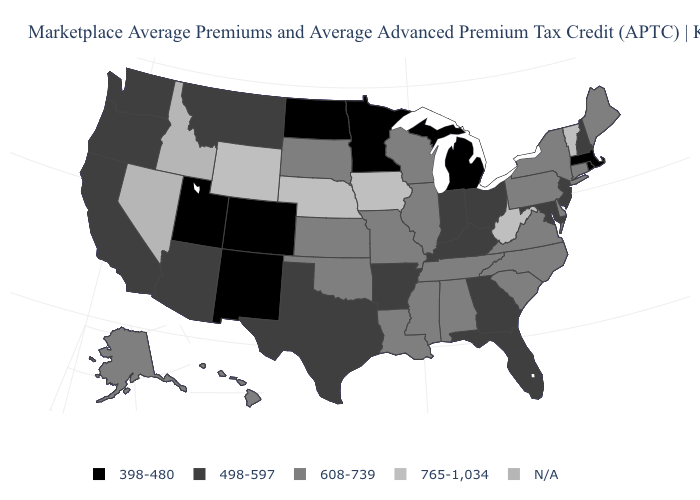Name the states that have a value in the range 498-597?
Be succinct. Arizona, Arkansas, California, Florida, Georgia, Indiana, Kentucky, Maryland, Montana, New Hampshire, New Jersey, Ohio, Oregon, Texas, Washington. What is the value of Minnesota?
Write a very short answer. 398-480. Name the states that have a value in the range N/A?
Concise answer only. Idaho, Nevada. Does the map have missing data?
Be succinct. Yes. Name the states that have a value in the range 398-480?
Answer briefly. Colorado, Massachusetts, Michigan, Minnesota, New Mexico, North Dakota, Rhode Island, Utah. Does the map have missing data?
Short answer required. Yes. What is the value of Iowa?
Give a very brief answer. 765-1,034. Name the states that have a value in the range 498-597?
Write a very short answer. Arizona, Arkansas, California, Florida, Georgia, Indiana, Kentucky, Maryland, Montana, New Hampshire, New Jersey, Ohio, Oregon, Texas, Washington. Name the states that have a value in the range N/A?
Concise answer only. Idaho, Nevada. What is the value of Kentucky?
Write a very short answer. 498-597. Which states have the highest value in the USA?
Write a very short answer. Iowa, Nebraska, Vermont, West Virginia, Wyoming. Name the states that have a value in the range 765-1,034?
Short answer required. Iowa, Nebraska, Vermont, West Virginia, Wyoming. What is the value of Hawaii?
Quick response, please. 608-739. Which states have the highest value in the USA?
Give a very brief answer. Iowa, Nebraska, Vermont, West Virginia, Wyoming. 